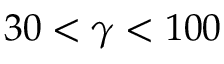Convert formula to latex. <formula><loc_0><loc_0><loc_500><loc_500>3 0 < \gamma < 1 0 0</formula> 